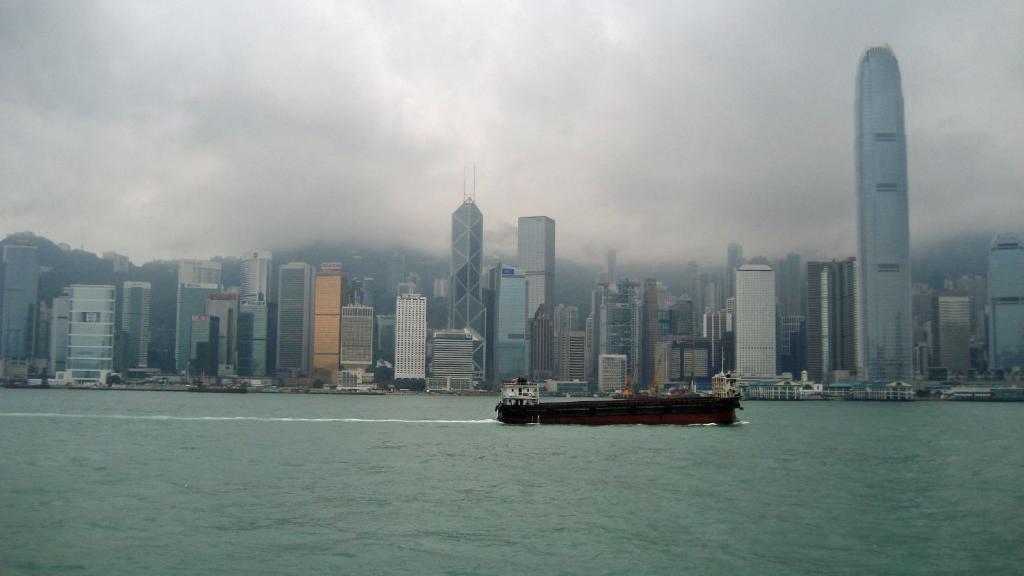Could you give a brief overview of what you see in this image? In this image there is a ship on the river, in the background there are huge buildings and the sky. 